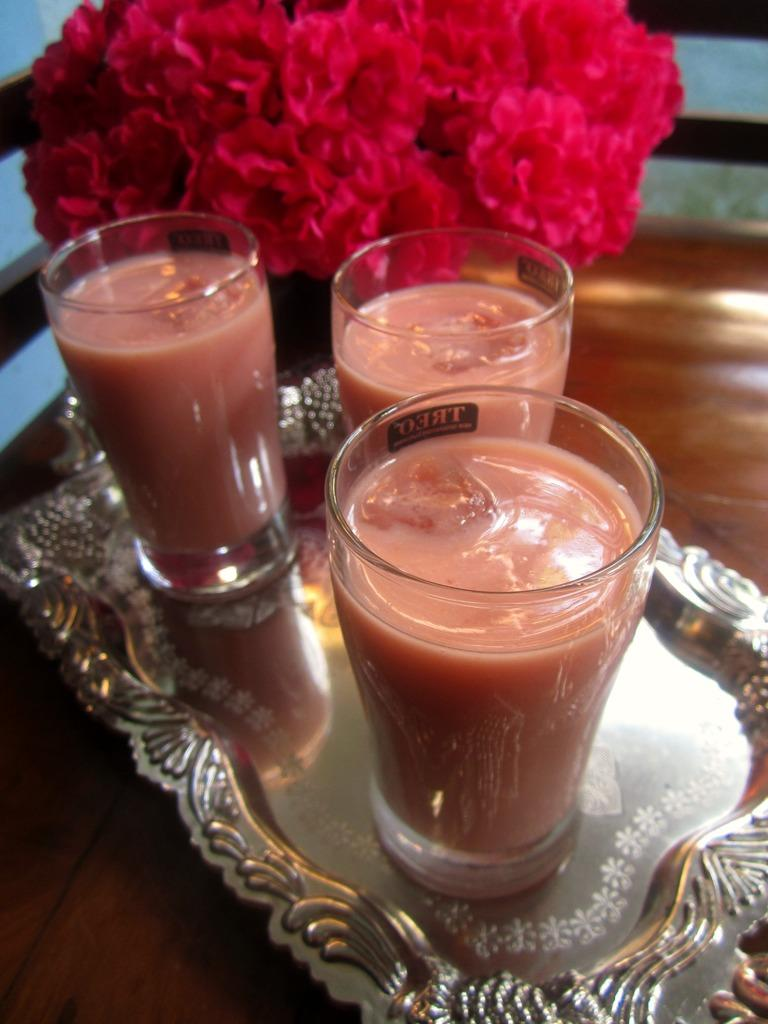How many glasses are on the steel tray in the image? There are 3 glasses on a steel tray in the image. What other objects can be seen in the image besides the glasses? There are flowers in the image. What type of surface are the objects placed on? The objects are on a wooden surface. Where are the babies playing in the park in the image? There are no babies or park present in the image; it features 3 glasses on a steel tray and flowers on a wooden surface. 